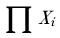Convert formula to latex. <formula><loc_0><loc_0><loc_500><loc_500>\prod X _ { i }</formula> 